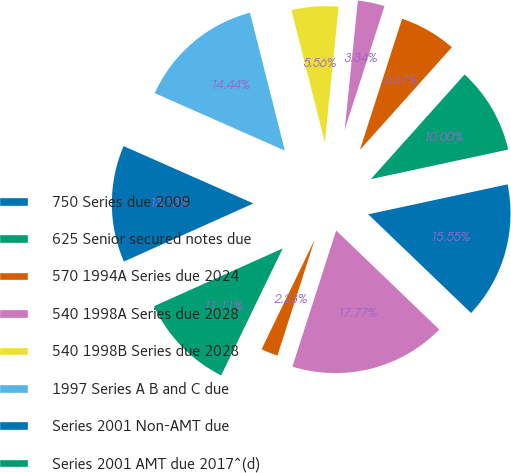Convert chart to OTSL. <chart><loc_0><loc_0><loc_500><loc_500><pie_chart><fcel>750 Series due 2009<fcel>625 Senior secured notes due<fcel>570 1994A Series due 2024<fcel>540 1998A Series due 2028<fcel>540 1998B Series due 2028<fcel>1997 Series A B and C due<fcel>Series 2001 Non-AMT due<fcel>Series 2001 AMT due 2017^(d)<fcel>Fair-market value adjustments<fcel>Total long-term debt gross<nl><fcel>15.55%<fcel>10.0%<fcel>6.67%<fcel>3.34%<fcel>5.56%<fcel>14.44%<fcel>13.33%<fcel>11.11%<fcel>2.23%<fcel>17.77%<nl></chart> 